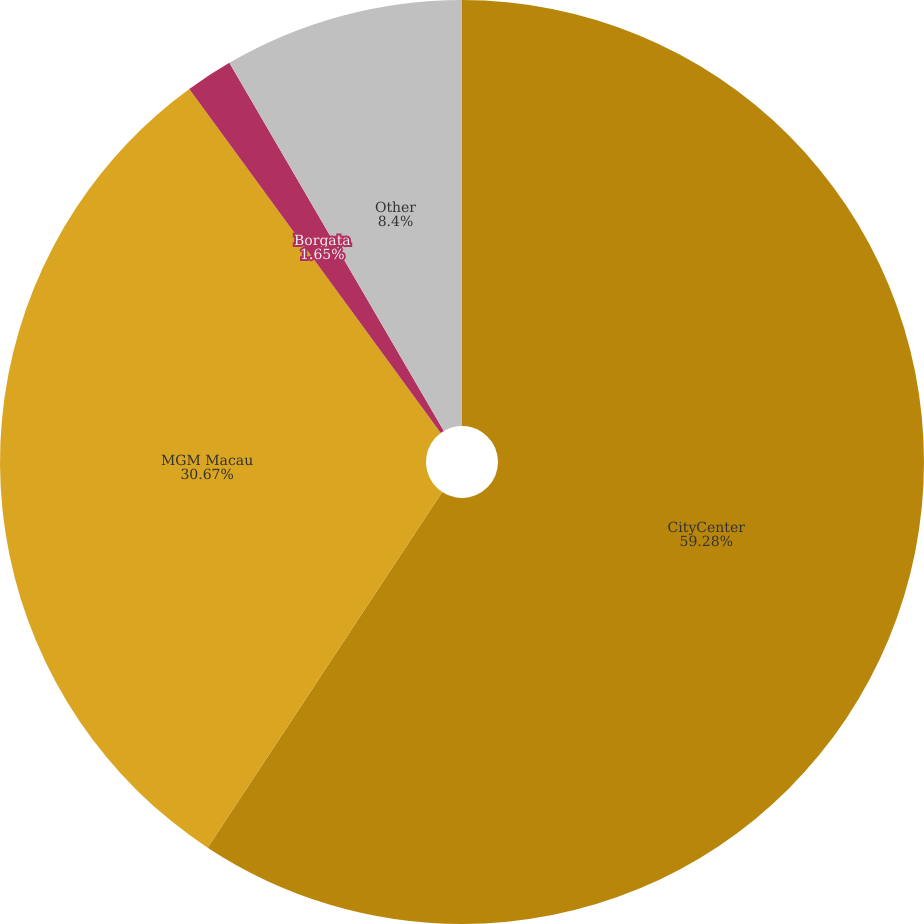Convert chart to OTSL. <chart><loc_0><loc_0><loc_500><loc_500><pie_chart><fcel>CityCenter<fcel>MGM Macau<fcel>Borgata<fcel>Other<nl><fcel>59.28%<fcel>30.67%<fcel>1.65%<fcel>8.4%<nl></chart> 